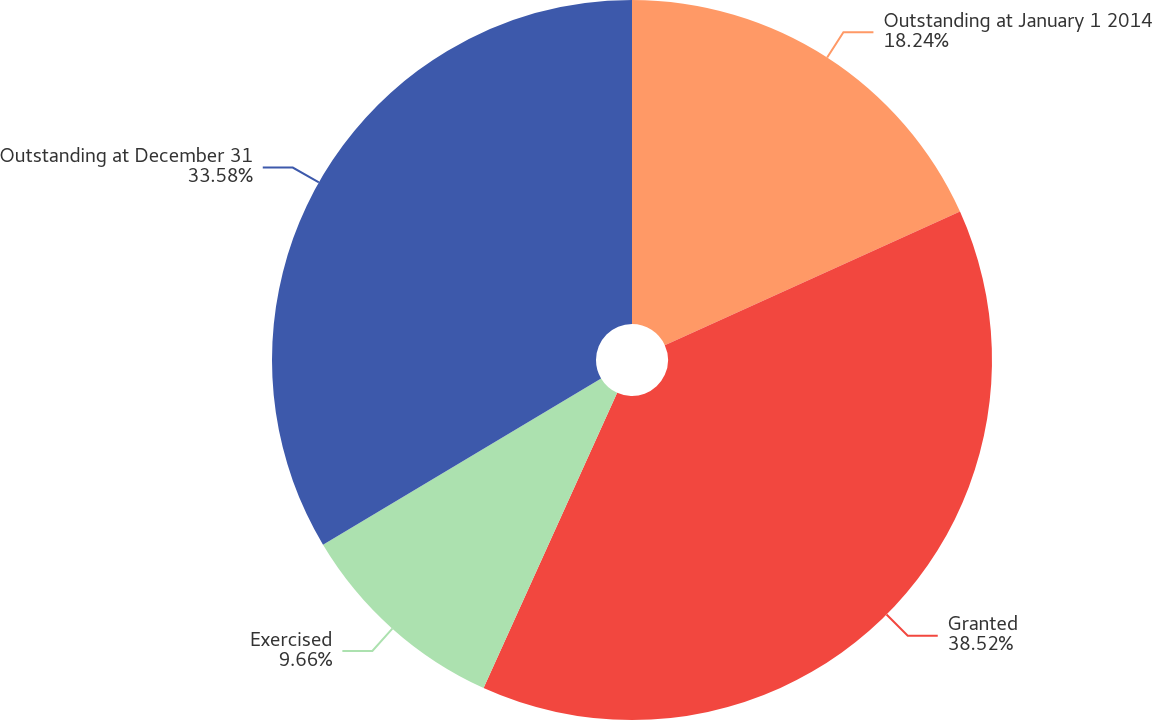Convert chart to OTSL. <chart><loc_0><loc_0><loc_500><loc_500><pie_chart><fcel>Outstanding at January 1 2014<fcel>Granted<fcel>Exercised<fcel>Outstanding at December 31<nl><fcel>18.24%<fcel>38.53%<fcel>9.66%<fcel>33.58%<nl></chart> 